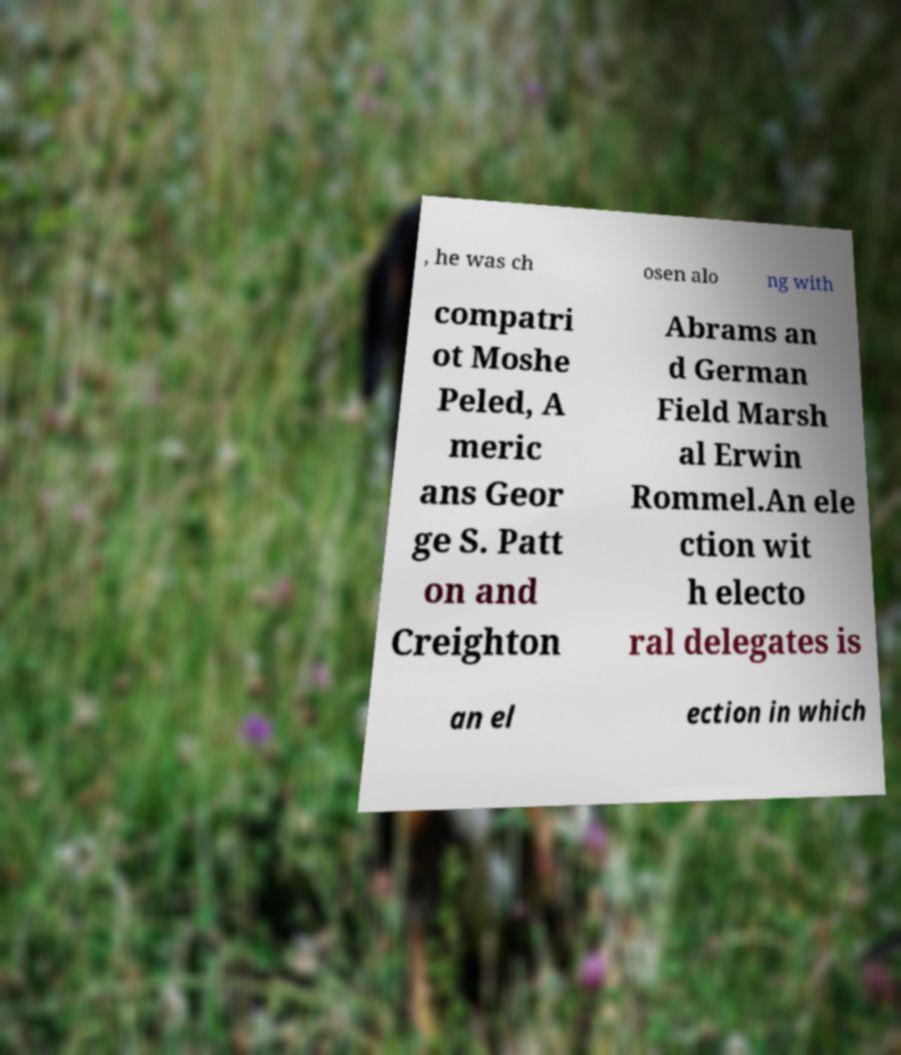Could you extract and type out the text from this image? , he was ch osen alo ng with compatri ot Moshe Peled, A meric ans Geor ge S. Patt on and Creighton Abrams an d German Field Marsh al Erwin Rommel.An ele ction wit h electo ral delegates is an el ection in which 